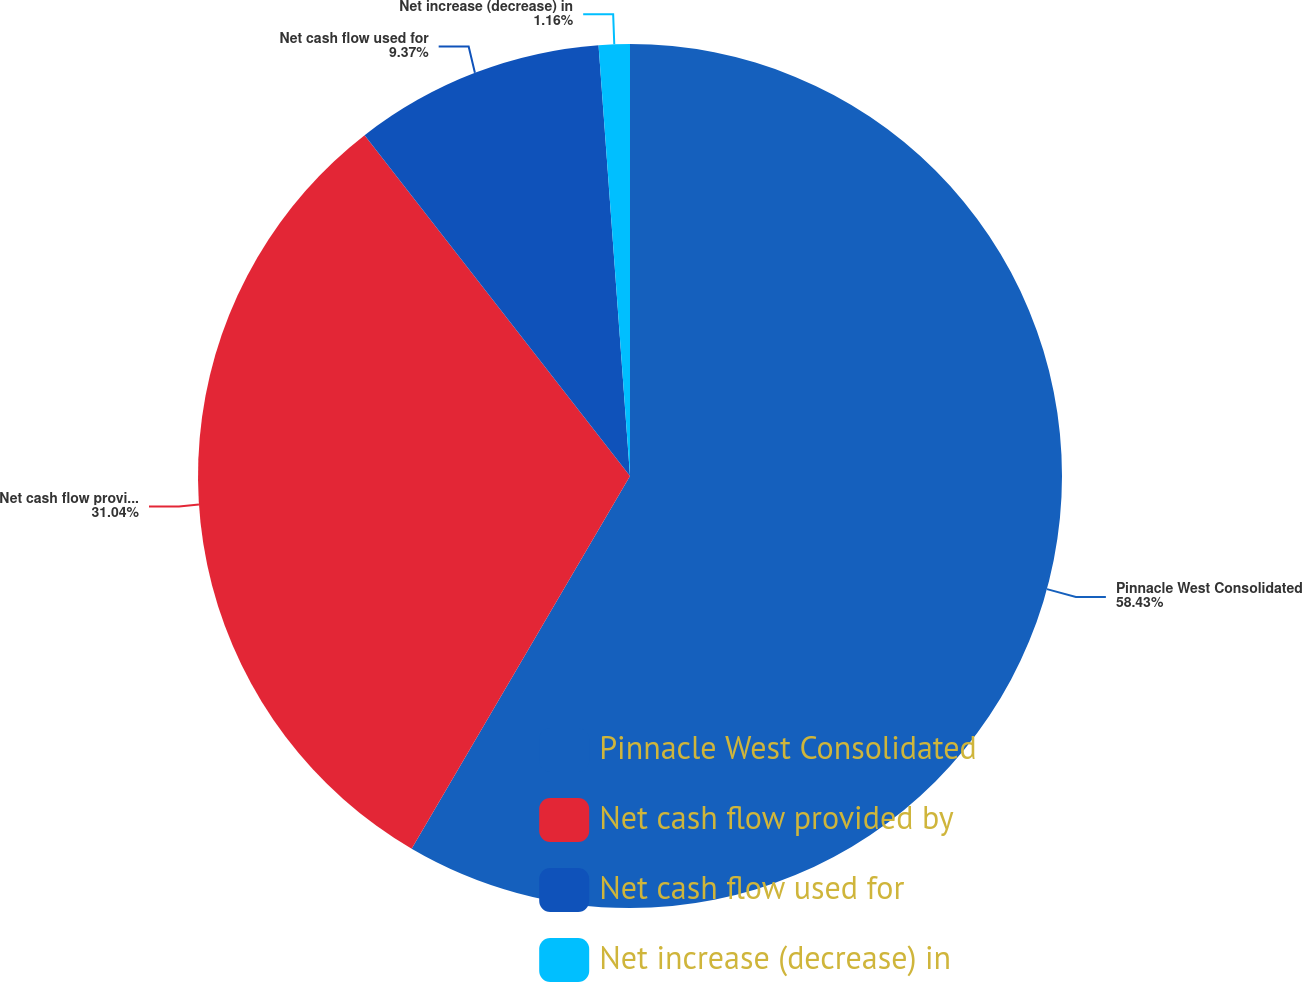Convert chart to OTSL. <chart><loc_0><loc_0><loc_500><loc_500><pie_chart><fcel>Pinnacle West Consolidated<fcel>Net cash flow provided by<fcel>Net cash flow used for<fcel>Net increase (decrease) in<nl><fcel>58.44%<fcel>31.04%<fcel>9.37%<fcel>1.16%<nl></chart> 